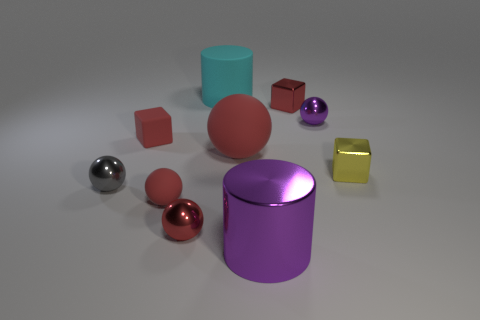How many red balls must be subtracted to get 1 red balls? 2 Subtract all purple shiny spheres. How many spheres are left? 4 Subtract all brown cubes. How many red spheres are left? 3 Subtract all yellow cubes. How many cubes are left? 2 Subtract all gray blocks. Subtract all brown spheres. How many blocks are left? 3 Subtract all cylinders. How many objects are left? 8 Subtract 0 green cubes. How many objects are left? 10 Subtract all red rubber balls. Subtract all tiny matte cylinders. How many objects are left? 8 Add 4 small shiny balls. How many small shiny balls are left? 7 Add 6 small blue cubes. How many small blue cubes exist? 6 